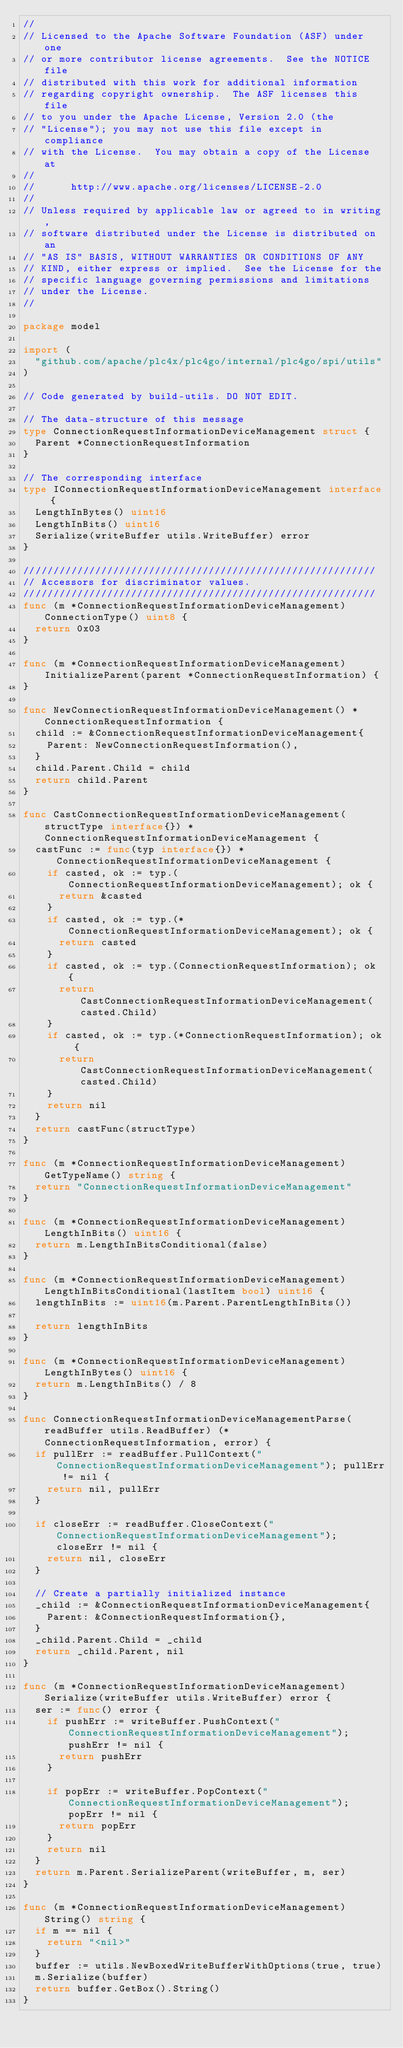Convert code to text. <code><loc_0><loc_0><loc_500><loc_500><_Go_>//
// Licensed to the Apache Software Foundation (ASF) under one
// or more contributor license agreements.  See the NOTICE file
// distributed with this work for additional information
// regarding copyright ownership.  The ASF licenses this file
// to you under the Apache License, Version 2.0 (the
// "License"); you may not use this file except in compliance
// with the License.  You may obtain a copy of the License at
//
//      http://www.apache.org/licenses/LICENSE-2.0
//
// Unless required by applicable law or agreed to in writing,
// software distributed under the License is distributed on an
// "AS IS" BASIS, WITHOUT WARRANTIES OR CONDITIONS OF ANY
// KIND, either express or implied.  See the License for the
// specific language governing permissions and limitations
// under the License.
//

package model

import (
	"github.com/apache/plc4x/plc4go/internal/plc4go/spi/utils"
)

// Code generated by build-utils. DO NOT EDIT.

// The data-structure of this message
type ConnectionRequestInformationDeviceManagement struct {
	Parent *ConnectionRequestInformation
}

// The corresponding interface
type IConnectionRequestInformationDeviceManagement interface {
	LengthInBytes() uint16
	LengthInBits() uint16
	Serialize(writeBuffer utils.WriteBuffer) error
}

///////////////////////////////////////////////////////////
// Accessors for discriminator values.
///////////////////////////////////////////////////////////
func (m *ConnectionRequestInformationDeviceManagement) ConnectionType() uint8 {
	return 0x03
}

func (m *ConnectionRequestInformationDeviceManagement) InitializeParent(parent *ConnectionRequestInformation) {
}

func NewConnectionRequestInformationDeviceManagement() *ConnectionRequestInformation {
	child := &ConnectionRequestInformationDeviceManagement{
		Parent: NewConnectionRequestInformation(),
	}
	child.Parent.Child = child
	return child.Parent
}

func CastConnectionRequestInformationDeviceManagement(structType interface{}) *ConnectionRequestInformationDeviceManagement {
	castFunc := func(typ interface{}) *ConnectionRequestInformationDeviceManagement {
		if casted, ok := typ.(ConnectionRequestInformationDeviceManagement); ok {
			return &casted
		}
		if casted, ok := typ.(*ConnectionRequestInformationDeviceManagement); ok {
			return casted
		}
		if casted, ok := typ.(ConnectionRequestInformation); ok {
			return CastConnectionRequestInformationDeviceManagement(casted.Child)
		}
		if casted, ok := typ.(*ConnectionRequestInformation); ok {
			return CastConnectionRequestInformationDeviceManagement(casted.Child)
		}
		return nil
	}
	return castFunc(structType)
}

func (m *ConnectionRequestInformationDeviceManagement) GetTypeName() string {
	return "ConnectionRequestInformationDeviceManagement"
}

func (m *ConnectionRequestInformationDeviceManagement) LengthInBits() uint16 {
	return m.LengthInBitsConditional(false)
}

func (m *ConnectionRequestInformationDeviceManagement) LengthInBitsConditional(lastItem bool) uint16 {
	lengthInBits := uint16(m.Parent.ParentLengthInBits())

	return lengthInBits
}

func (m *ConnectionRequestInformationDeviceManagement) LengthInBytes() uint16 {
	return m.LengthInBits() / 8
}

func ConnectionRequestInformationDeviceManagementParse(readBuffer utils.ReadBuffer) (*ConnectionRequestInformation, error) {
	if pullErr := readBuffer.PullContext("ConnectionRequestInformationDeviceManagement"); pullErr != nil {
		return nil, pullErr
	}

	if closeErr := readBuffer.CloseContext("ConnectionRequestInformationDeviceManagement"); closeErr != nil {
		return nil, closeErr
	}

	// Create a partially initialized instance
	_child := &ConnectionRequestInformationDeviceManagement{
		Parent: &ConnectionRequestInformation{},
	}
	_child.Parent.Child = _child
	return _child.Parent, nil
}

func (m *ConnectionRequestInformationDeviceManagement) Serialize(writeBuffer utils.WriteBuffer) error {
	ser := func() error {
		if pushErr := writeBuffer.PushContext("ConnectionRequestInformationDeviceManagement"); pushErr != nil {
			return pushErr
		}

		if popErr := writeBuffer.PopContext("ConnectionRequestInformationDeviceManagement"); popErr != nil {
			return popErr
		}
		return nil
	}
	return m.Parent.SerializeParent(writeBuffer, m, ser)
}

func (m *ConnectionRequestInformationDeviceManagement) String() string {
	if m == nil {
		return "<nil>"
	}
	buffer := utils.NewBoxedWriteBufferWithOptions(true, true)
	m.Serialize(buffer)
	return buffer.GetBox().String()
}
</code> 